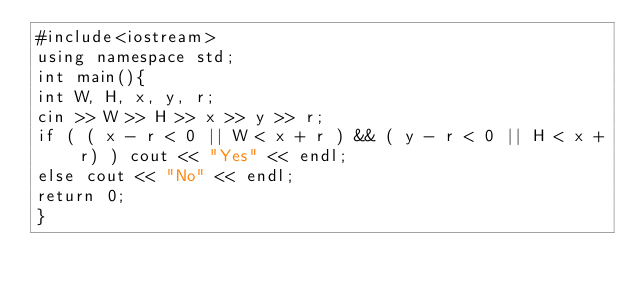Convert code to text. <code><loc_0><loc_0><loc_500><loc_500><_C++_>#include<iostream>
using namespace std;
int main(){
int W, H, x, y, r;
cin >> W >> H >> x >> y >> r;
if ( ( x - r < 0 || W < x + r ) && ( y - r < 0 || H < x + r) ) cout << "Yes" << endl;
else cout << "No" << endl;
return 0;
}</code> 